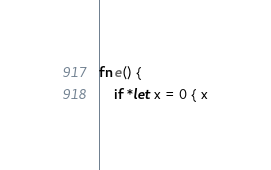<code> <loc_0><loc_0><loc_500><loc_500><_Rust_>fn e() {
    if *let x = 0 { x
</code> 